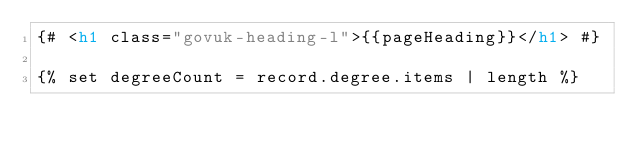<code> <loc_0><loc_0><loc_500><loc_500><_HTML_>{# <h1 class="govuk-heading-l">{{pageHeading}}</h1> #}

{% set degreeCount = record.degree.items | length %}
</code> 